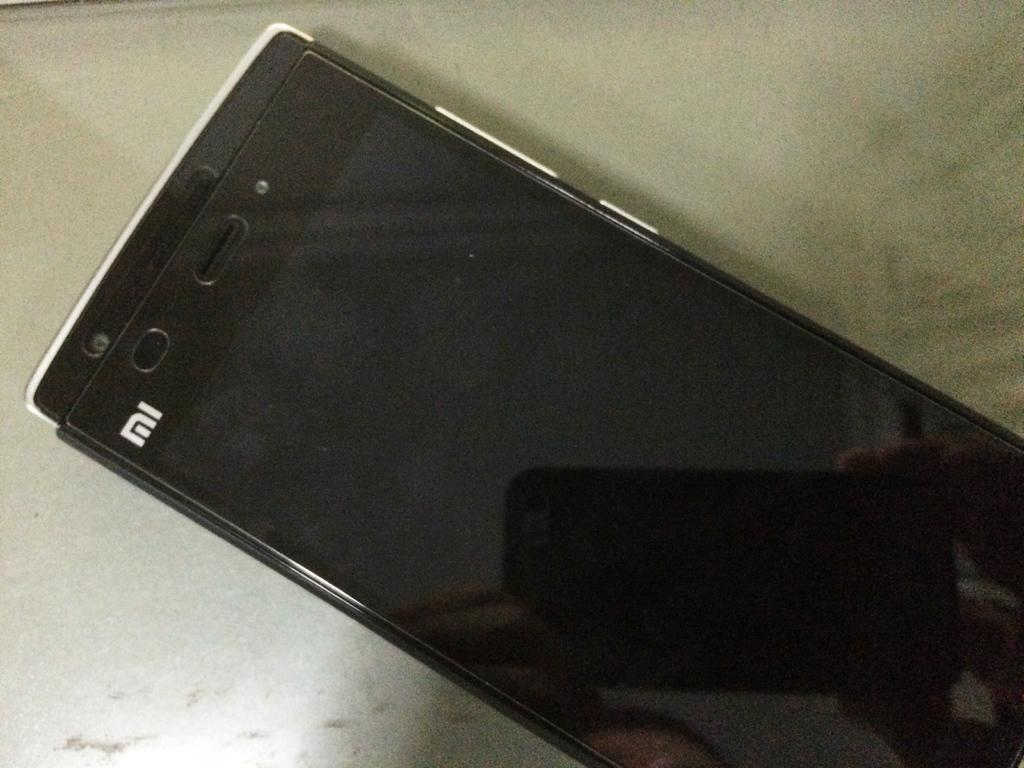What type of mobile is visible in the image? There is a MI mobile in the image. What is the color of the surface on which the MI mobile is placed? The MI mobile is on a white surface. Can you describe any additional features or elements in the image? There is a shadow of another mobile on the MI mobile. Where can the kittens be seen playing in the image? There are no kittens present in the image. 